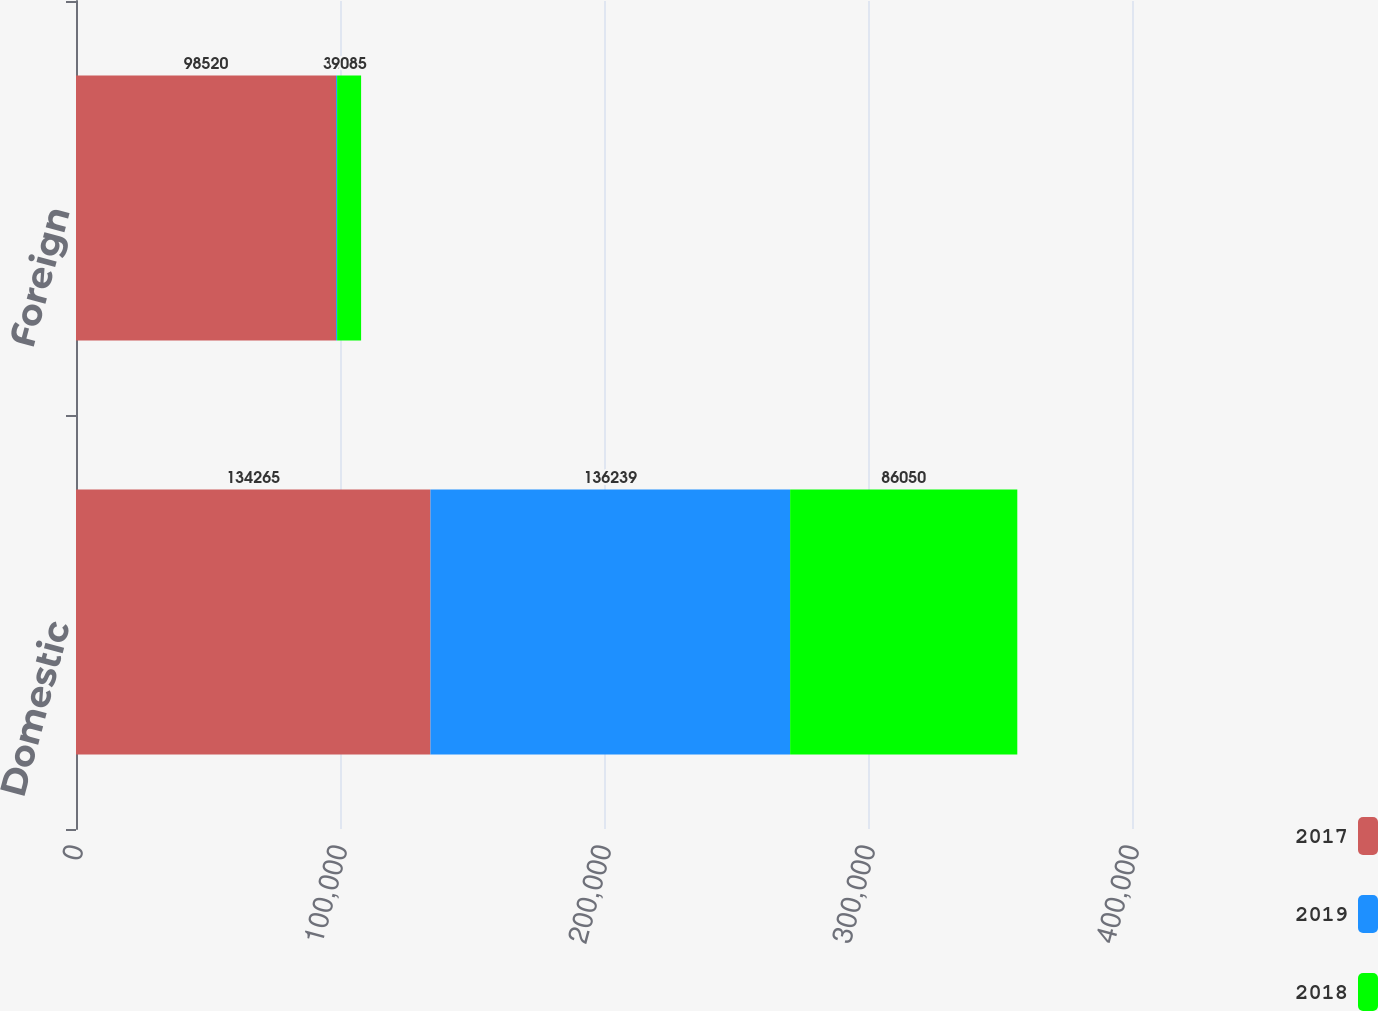<chart> <loc_0><loc_0><loc_500><loc_500><stacked_bar_chart><ecel><fcel>Domestic<fcel>Foreign<nl><fcel>2017<fcel>134265<fcel>98520<nl><fcel>2019<fcel>136239<fcel>386<nl><fcel>2018<fcel>86050<fcel>9085<nl></chart> 